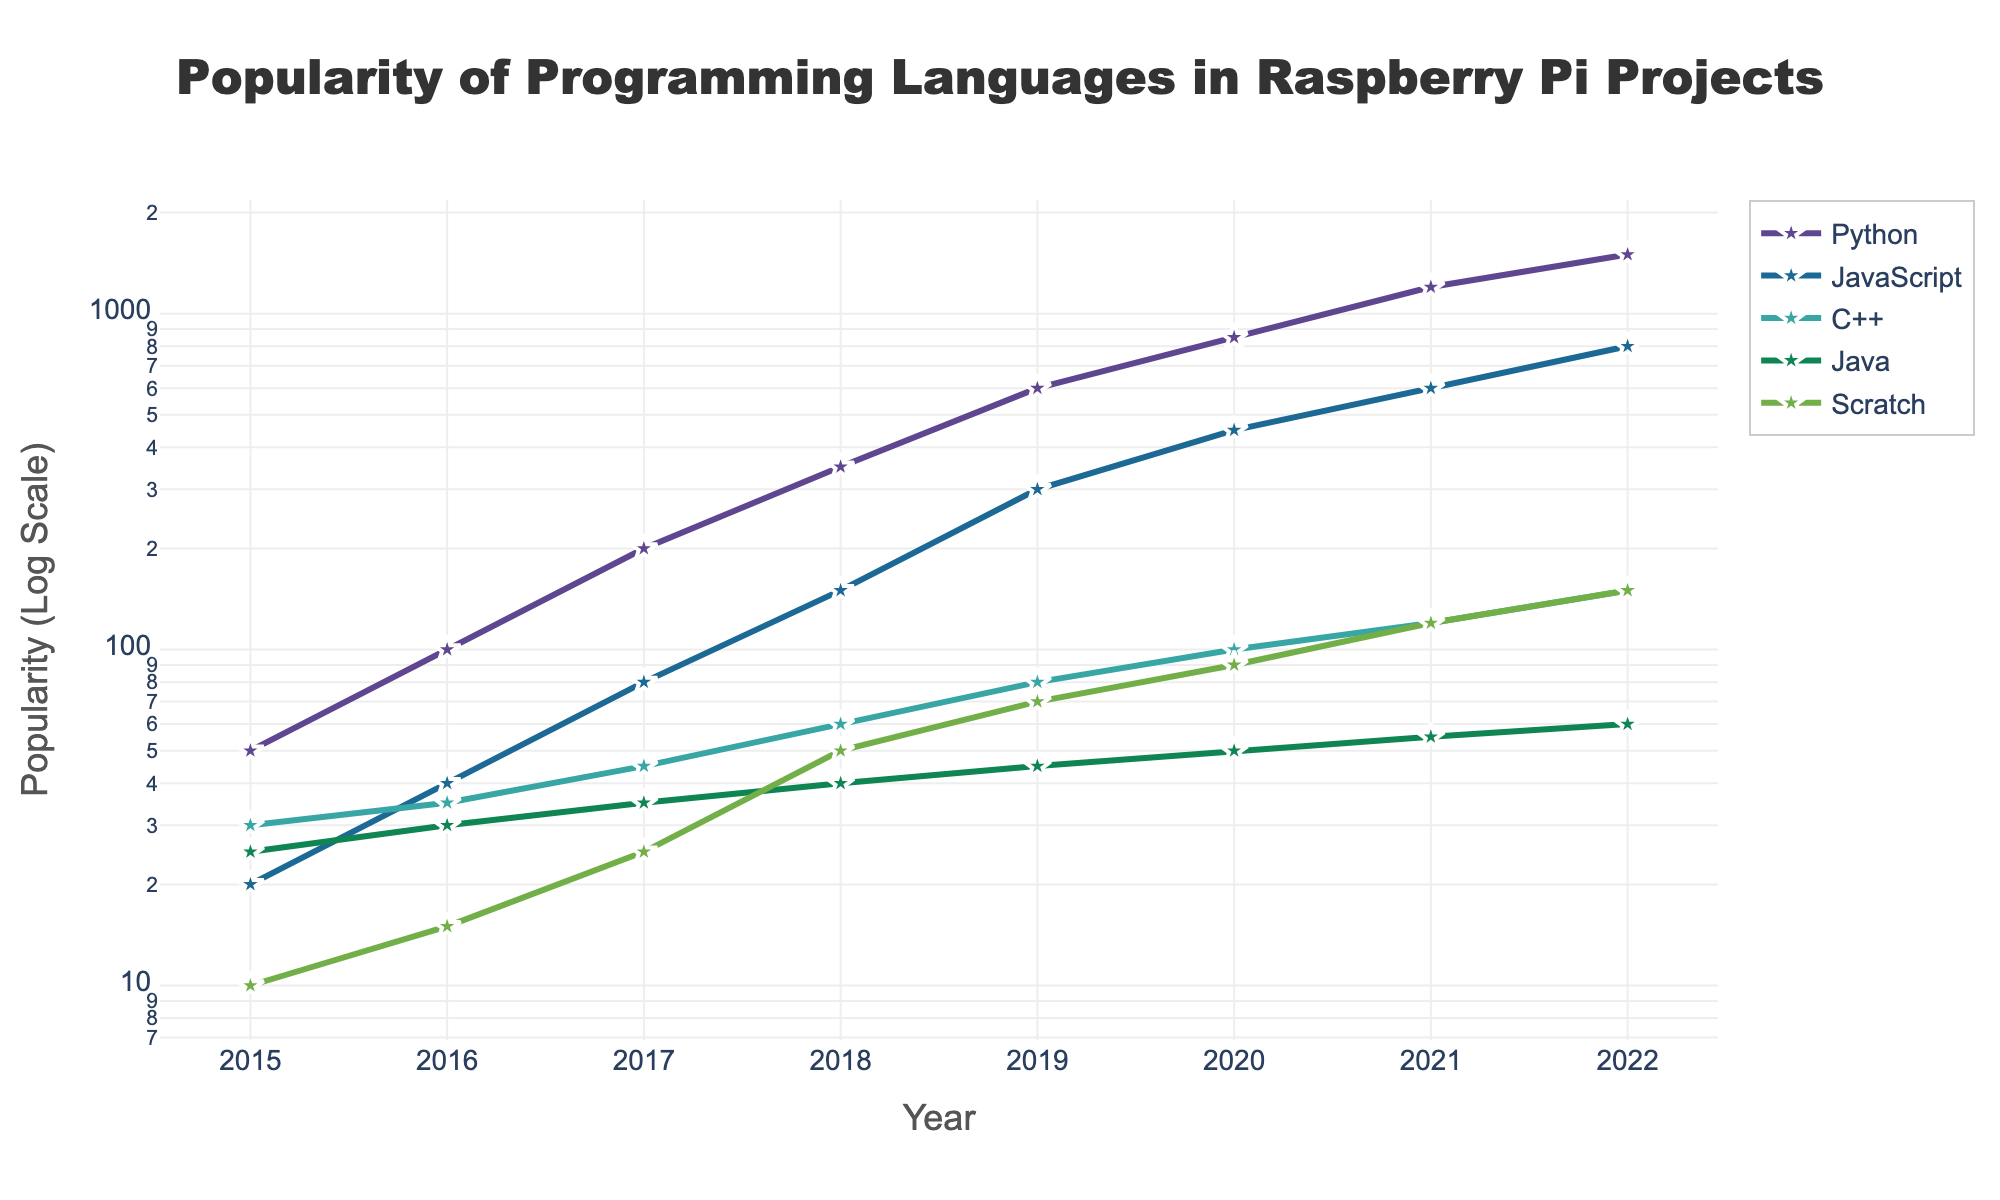what is the title of the figure? The title of the figure is placed prominently at the top and reads: "Popularity of Programming Languages in Raspberry Pi Projects"
Answer: Popularity of Programming Languages in Raspberry Pi Projects what years are included in the plot? The x-axis of the plot shows the timeline from 2015 to 2022, which includes all these years.
Answer: 2015 to 2022 what programming language has the highest popularity in 2022? By looking at the end of the timeline for the year 2022, Python has the highest popularity with the highest data point on the plot.
Answer: Python how many programming languages are plotted in the figure? The legend shows symbols for 5 different programming languages: Python, JavaScript, C++, Java, and Scratch.
Answer: 5 what color represents JavaScript in the plot? In the legend, JavaScript is associated with a specific color used for its line and markers. The color is purple.
Answer: purple what is the popularity of C++ in 2019? By finding the data point for C++ in the year 2019 on the x-axis, the popularity value given on the y-axis is 80.
Answer: 80 which programming languages show a continuous increase in popularity from 2015 to 2022? By following the lines for each programming language from left (2015) to right (2022), Python, JavaScript, Scratch, and C++ all show a continuous increase, while Java remains relatively flat with slight increases.
Answer: Python, JavaScript, Scratch, C++ which year did Python surpass 1000 in popularity? By tracing the Python line to where it crosses the 1000 mark on the y-axis, we can see that this happened in the year 2021.
Answer: 2021 which programming language had the smallest increase in popularity from 2015 to 2022? Comparing the starting and ending points of each line, Java had the smallest increase, starting at 25 in 2015 and ending at 60 in 2022.
Answer: Java what is the ratio of Python's popularity to JavaScript's popularity in 2016? Python had a popularity of 100 and JavaScript had 40 in 2016. The ratio of Python's popularity to JavaScript's popularity is 100/40 = 2.5.
Answer: 2.5 